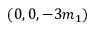Convert formula to latex. <formula><loc_0><loc_0><loc_500><loc_500>( 0 , 0 , - 3 m _ { 1 } )</formula> 